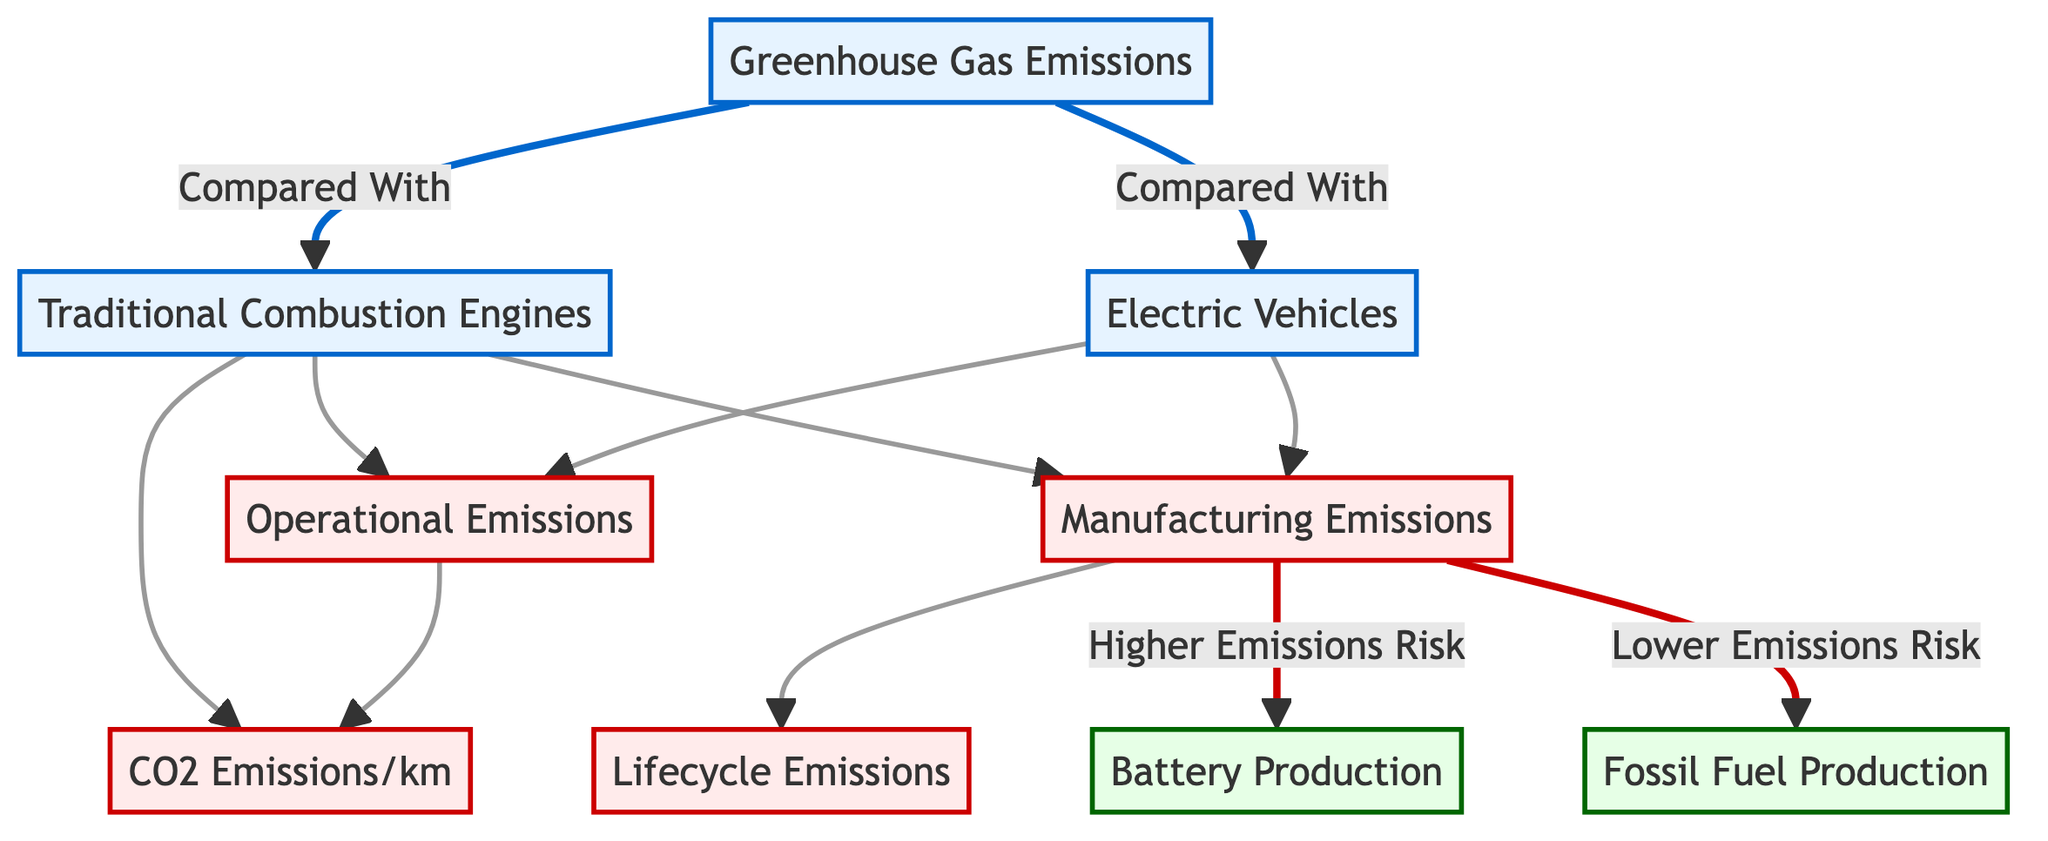What are the two main types of vehicles compared in the diagram? The diagram clearly indicates two main categories being compared: 'Traditional Combustion Engines' and 'Electric Vehicles'. These categories are represented as two distinct nodes under the main heading of 'Greenhouse Gas Emissions'.
Answer: Traditional Combustion Engines, Electric Vehicles How many types of emissions are represented in the diagram? There are four types of emissions listed in the diagram: 'Operational Emissions', 'Manufacturing Emissions', 'CO2 Emissions/km', and 'Lifecycle Emissions'. The nodes representing these emissions are directly connected to both types of vehicles. By counting these nodes, we determine the total types of emissions.
Answer: Four Which type of vehicle has higher manufacturing emissions risk? According to the diagram, 'Traditional Combustion Engines' has a higher emissions risk associated with manufacturing emissions, specifically linked to 'Battery Production'. The node for manufacturing emissions risk is only connected from the traditional engines to the battery production process.
Answer: Traditional Combustion Engines What do 'Battery Production' and 'Fossil Fuel Production' represent in the context of emissions? Both 'Battery Production' and 'Fossil Fuel Production' are categorized as processes that contribute to the overall manufacturing emissions of vehicles. 'Battery Production' is linked to the electric vehicles and has a risk count associated with it, while 'Fossil Fuel Production' is linked to traditional combustion.
Answer: Processes What is the relationship between operational emissions and the types of vehicles? In the diagram, operational emissions are connected to both vehicle types, implying that both 'Traditional Combustion Engines' and 'Electric Vehicles' produce operational emissions. This means that operational emissions are a common factor in the emissions analysis of both vehicle categories.
Answer: Connected to both Which type of vehicle has lower emissions risk due to fossil fuel production? The diagram shows that 'Electric Vehicles' have a lower emissions risk tied to 'Fossil Fuel Production', indicating a favorable environmental impact regarding this process compared to traditional vehicles. The connection suggests that electric vehicles are less impacted by fossil fuel production emissions.
Answer: Electric Vehicles 